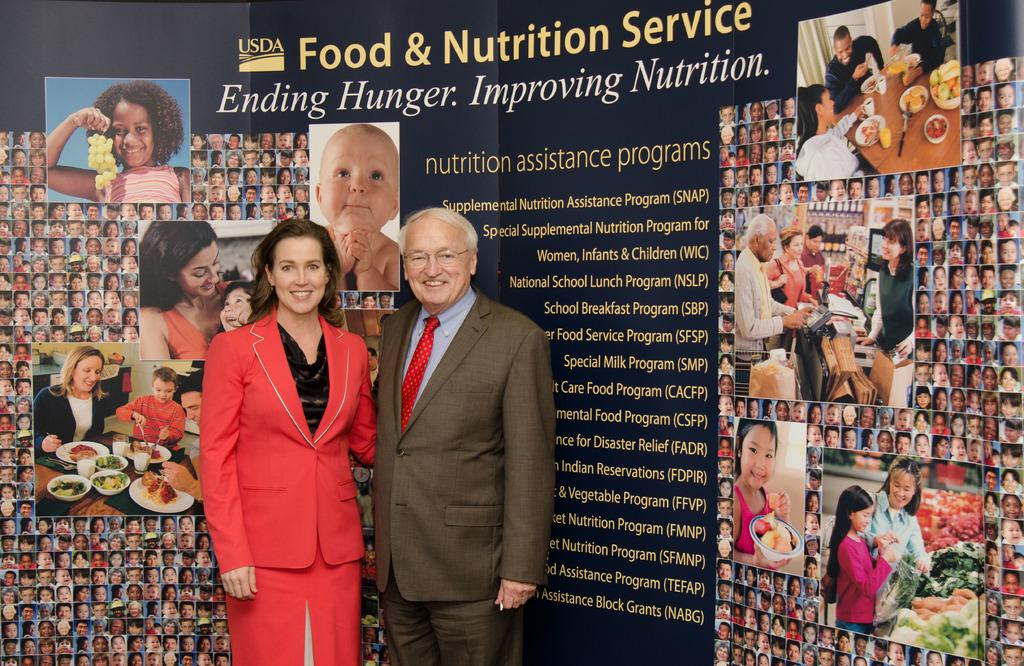What can be seen in the foreground of the image? There are persons standing in the front of the image. What are the expressions of the persons in the image? The persons are smiling. What is located in the background of the image? There is a board in the background of the image. What is written or depicted on the board? The board has text and images on it. What type of magic trick is being performed by the persons in the image? There is no indication of a magic trick being performed in the image; the persons are simply standing and smiling. 